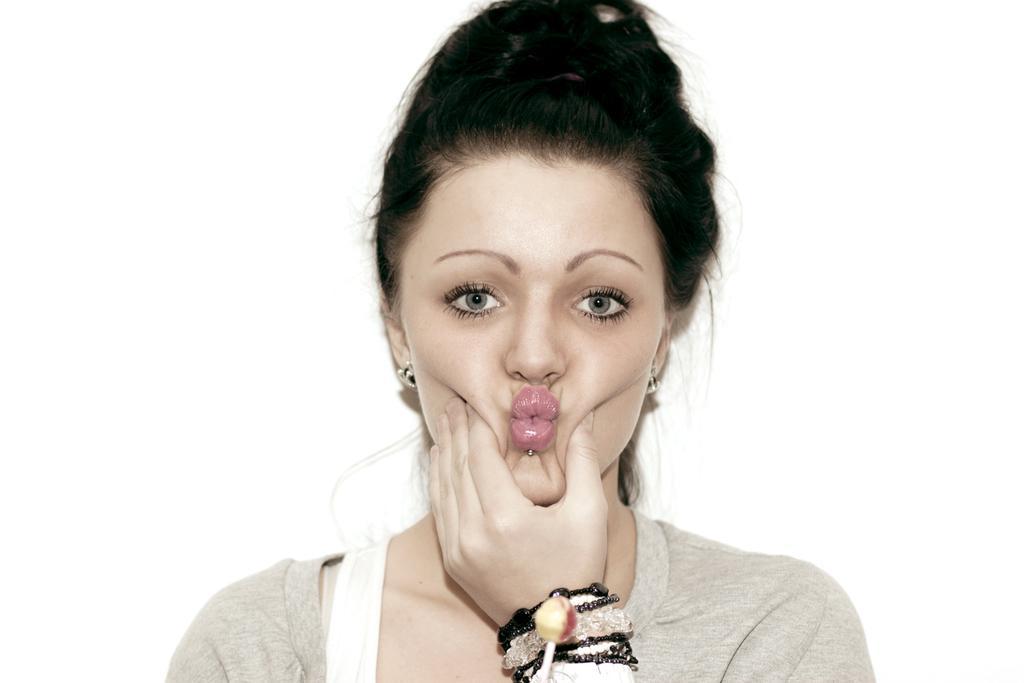Could you give a brief overview of what you see in this image? In this picture I can see a woman holding her cheeks, there is a lollipop, and there is white background. 